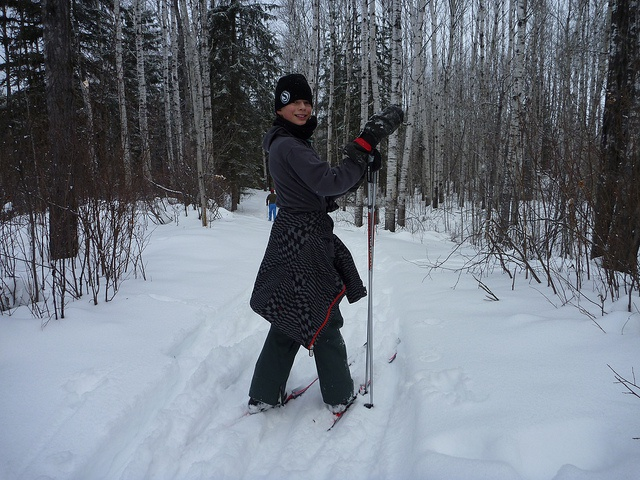Describe the objects in this image and their specific colors. I can see people in black, gray, and maroon tones and skis in black, darkgray, and gray tones in this image. 